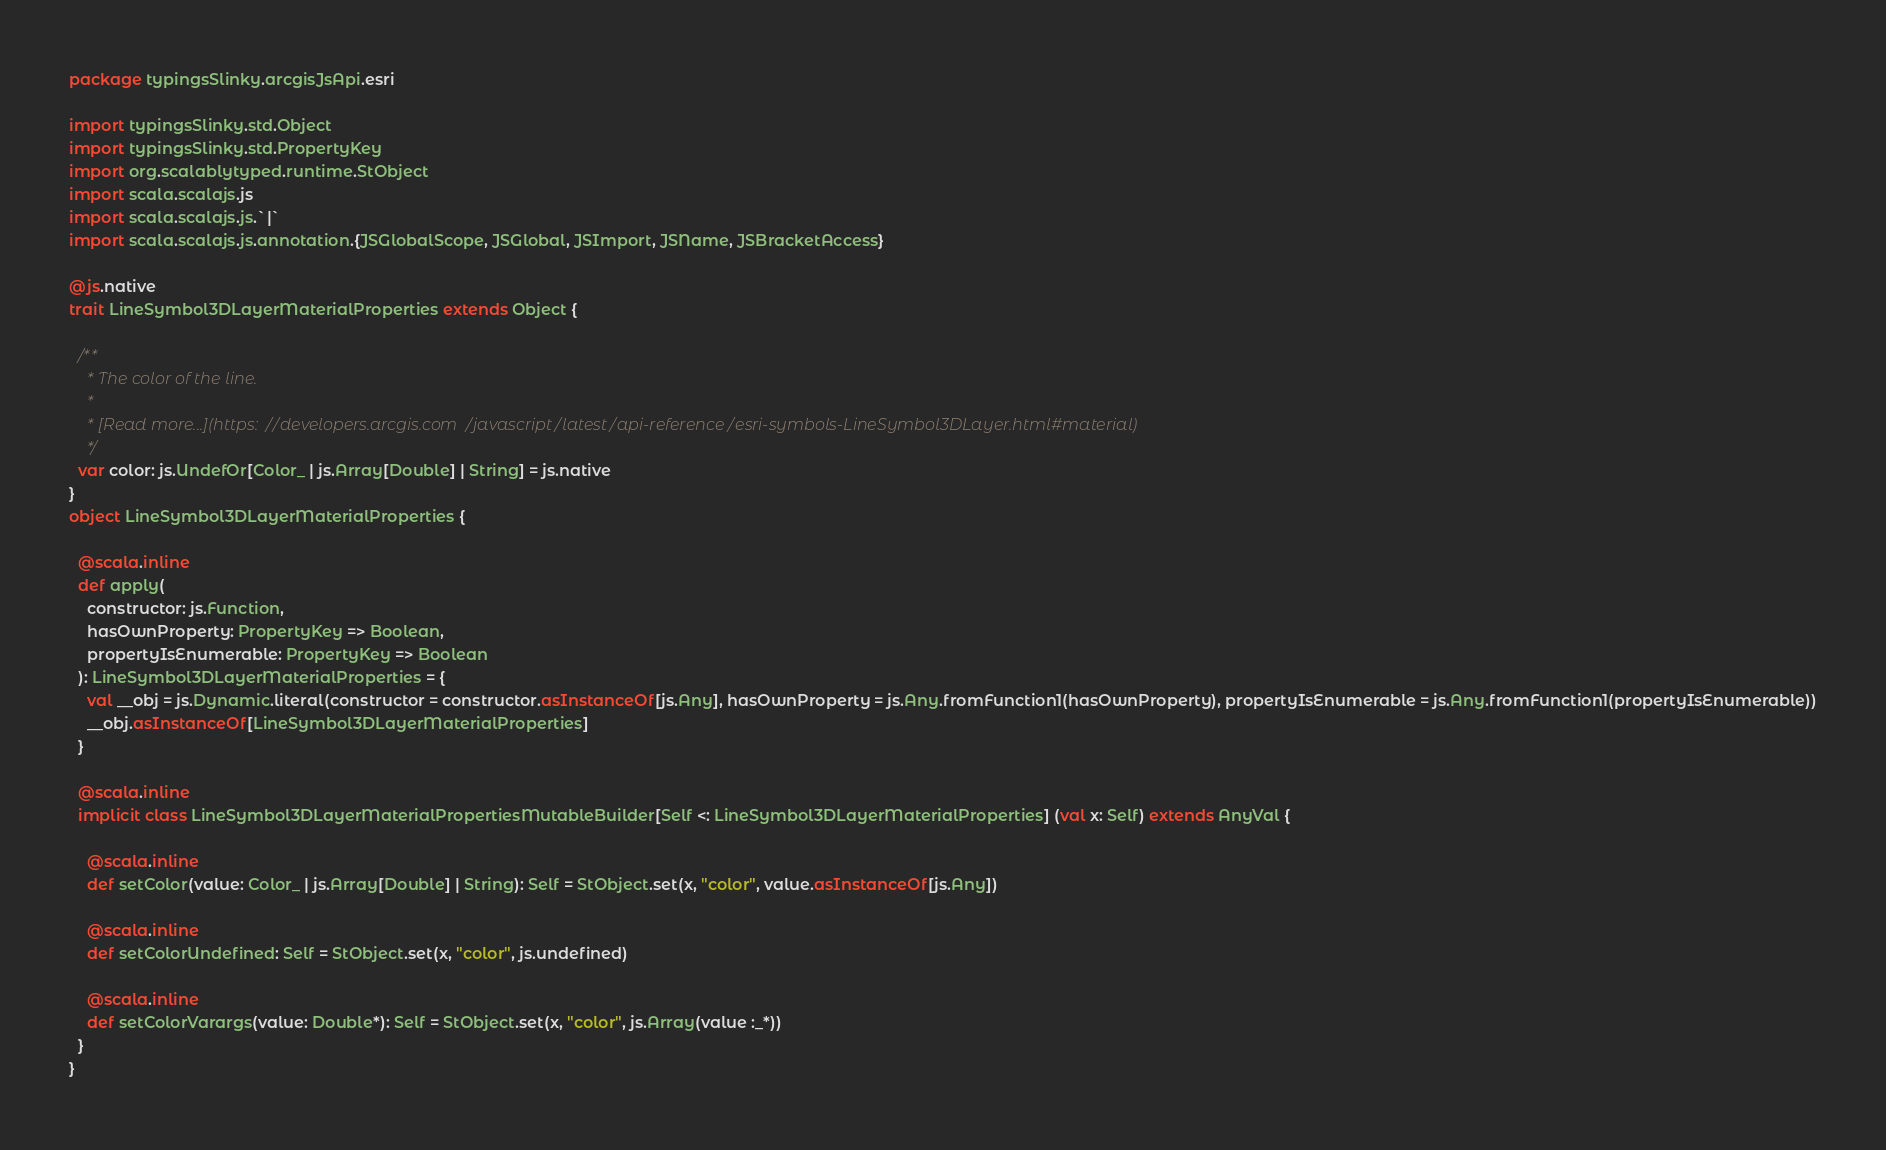<code> <loc_0><loc_0><loc_500><loc_500><_Scala_>package typingsSlinky.arcgisJsApi.esri

import typingsSlinky.std.Object
import typingsSlinky.std.PropertyKey
import org.scalablytyped.runtime.StObject
import scala.scalajs.js
import scala.scalajs.js.`|`
import scala.scalajs.js.annotation.{JSGlobalScope, JSGlobal, JSImport, JSName, JSBracketAccess}

@js.native
trait LineSymbol3DLayerMaterialProperties extends Object {
  
  /**
    * The color of the line.
    *
    * [Read more...](https://developers.arcgis.com/javascript/latest/api-reference/esri-symbols-LineSymbol3DLayer.html#material)
    */
  var color: js.UndefOr[Color_ | js.Array[Double] | String] = js.native
}
object LineSymbol3DLayerMaterialProperties {
  
  @scala.inline
  def apply(
    constructor: js.Function,
    hasOwnProperty: PropertyKey => Boolean,
    propertyIsEnumerable: PropertyKey => Boolean
  ): LineSymbol3DLayerMaterialProperties = {
    val __obj = js.Dynamic.literal(constructor = constructor.asInstanceOf[js.Any], hasOwnProperty = js.Any.fromFunction1(hasOwnProperty), propertyIsEnumerable = js.Any.fromFunction1(propertyIsEnumerable))
    __obj.asInstanceOf[LineSymbol3DLayerMaterialProperties]
  }
  
  @scala.inline
  implicit class LineSymbol3DLayerMaterialPropertiesMutableBuilder[Self <: LineSymbol3DLayerMaterialProperties] (val x: Self) extends AnyVal {
    
    @scala.inline
    def setColor(value: Color_ | js.Array[Double] | String): Self = StObject.set(x, "color", value.asInstanceOf[js.Any])
    
    @scala.inline
    def setColorUndefined: Self = StObject.set(x, "color", js.undefined)
    
    @scala.inline
    def setColorVarargs(value: Double*): Self = StObject.set(x, "color", js.Array(value :_*))
  }
}
</code> 